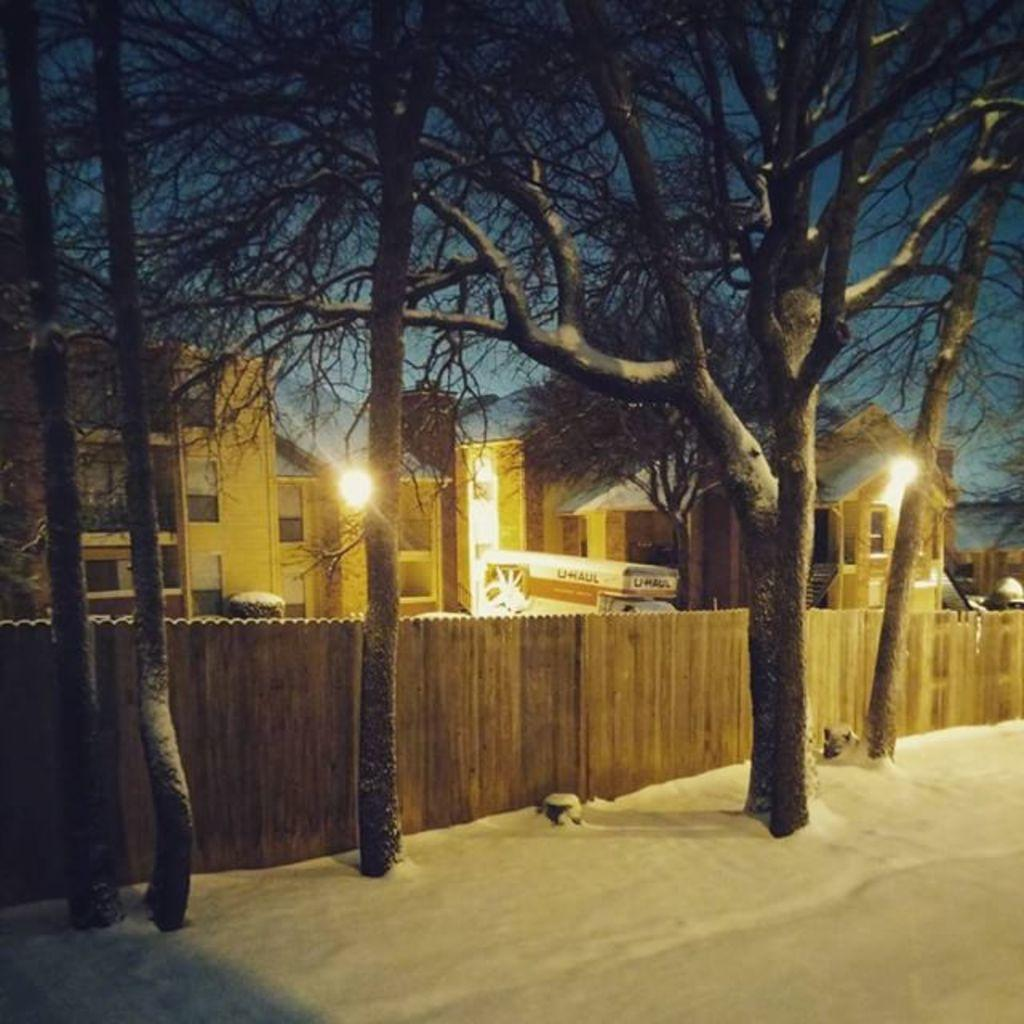What type of vegetation can be seen in the image? There are trees beside a fence in the image. What is covering the ground in the image? There is snow at the bottom of the image. What can be seen in the distance in the image? There are buildings in the background of the image. What color are the lights on the buildings? The lights on the buildings are yellow in color. Can you tell me how many lettuce leaves are on the floor in the image? There is no lettuce present in the image; it features trees, snow, buildings, and yellow lights. What type of berry is growing on the fence in the image? There are no berries visible on the fence in the image; it only shows trees and a fence. 